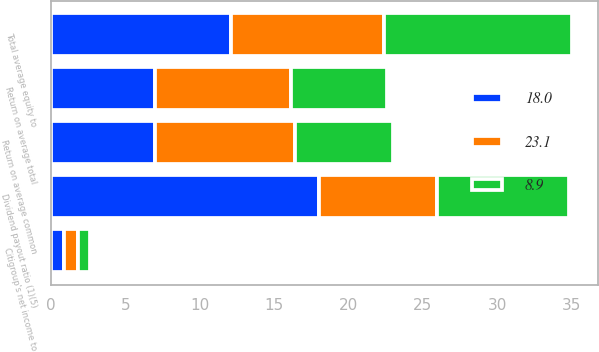Convert chart to OTSL. <chart><loc_0><loc_0><loc_500><loc_500><stacked_bar_chart><ecel><fcel>Citigroup's net income to<fcel>Return on average common<fcel>Return on average total<fcel>Total average equity to<fcel>Dividend payout ratio (1)(5)<nl><fcel>23.1<fcel>0.94<fcel>9.4<fcel>9.1<fcel>10.3<fcel>7.95<nl><fcel>18<fcel>0.84<fcel>7<fcel>7<fcel>12.1<fcel>18<nl><fcel>8.9<fcel>0.82<fcel>6.6<fcel>6.5<fcel>12.6<fcel>8.9<nl></chart> 